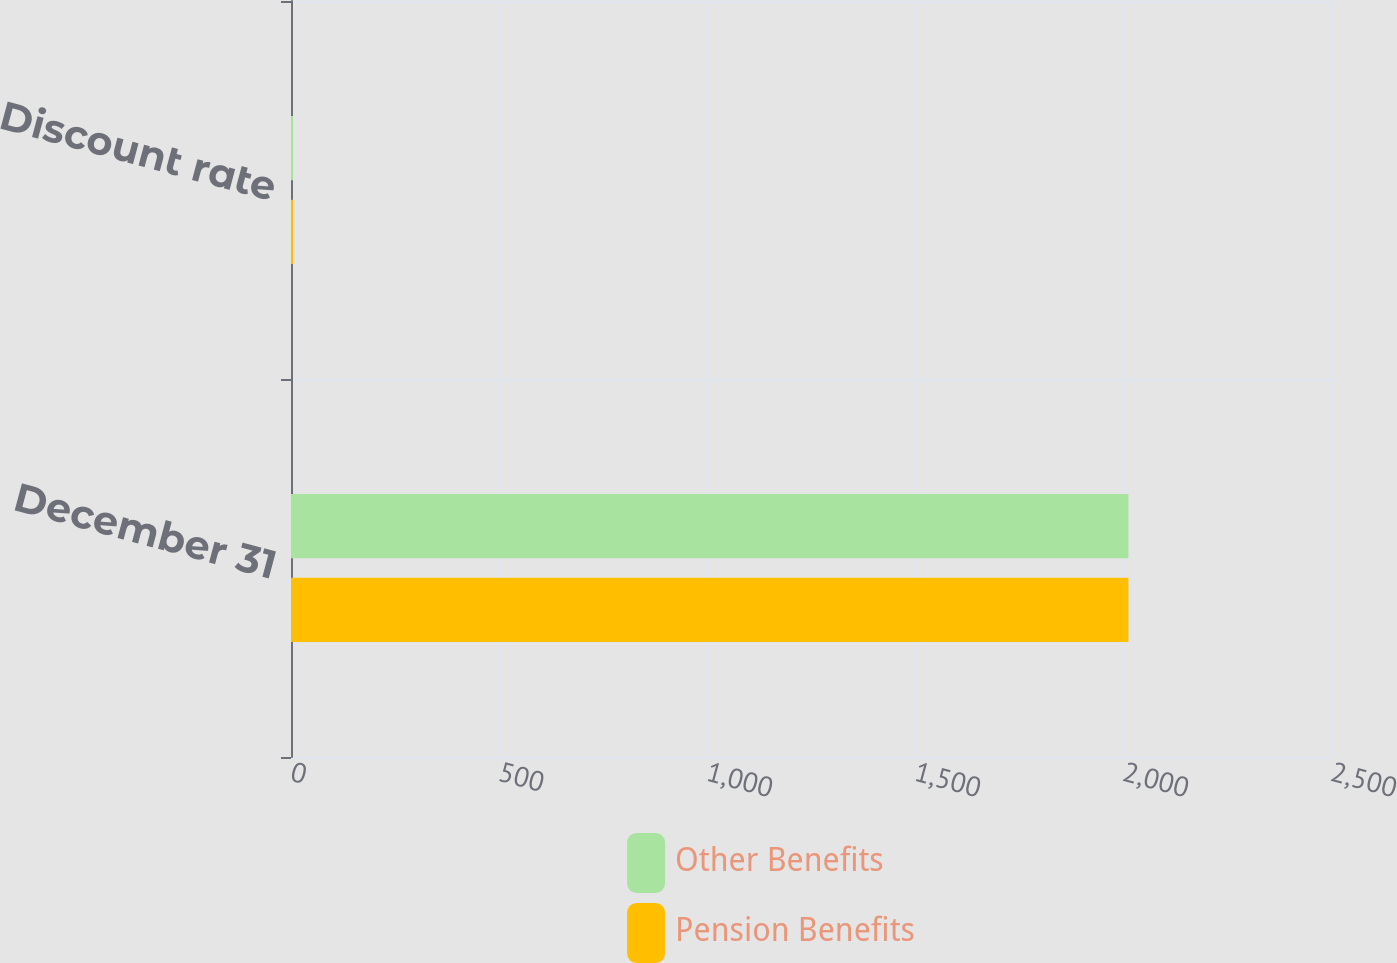<chart> <loc_0><loc_0><loc_500><loc_500><stacked_bar_chart><ecel><fcel>December 31<fcel>Discount rate<nl><fcel>Other Benefits<fcel>2013<fcel>4.75<nl><fcel>Pension Benefits<fcel>2013<fcel>4.75<nl></chart> 